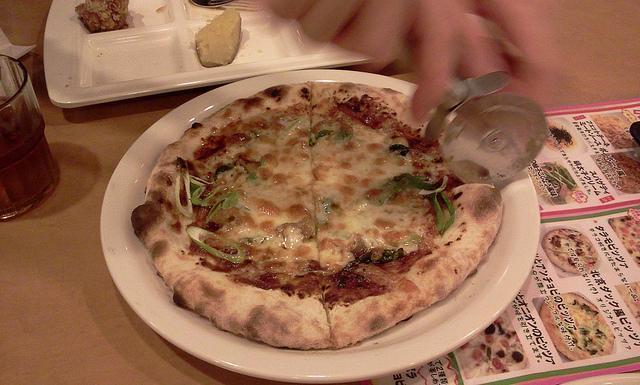How many drinks are shown?
Give a very brief answer. 1. How many elephants are there?
Give a very brief answer. 0. 